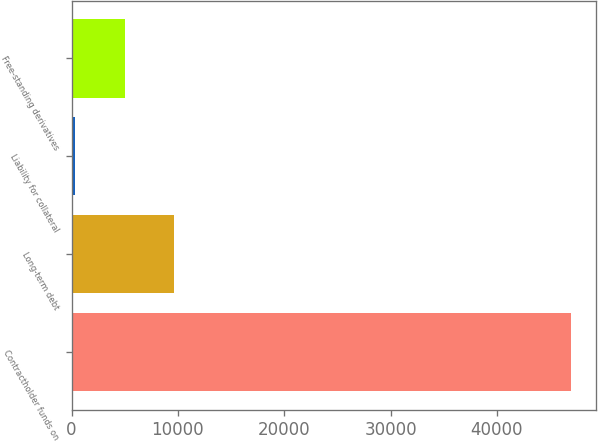Convert chart. <chart><loc_0><loc_0><loc_500><loc_500><bar_chart><fcel>Contractholder funds on<fcel>Long-term debt<fcel>Liability for collateral<fcel>Free-standing derivatives<nl><fcel>46972<fcel>9666.4<fcel>340<fcel>5003.2<nl></chart> 